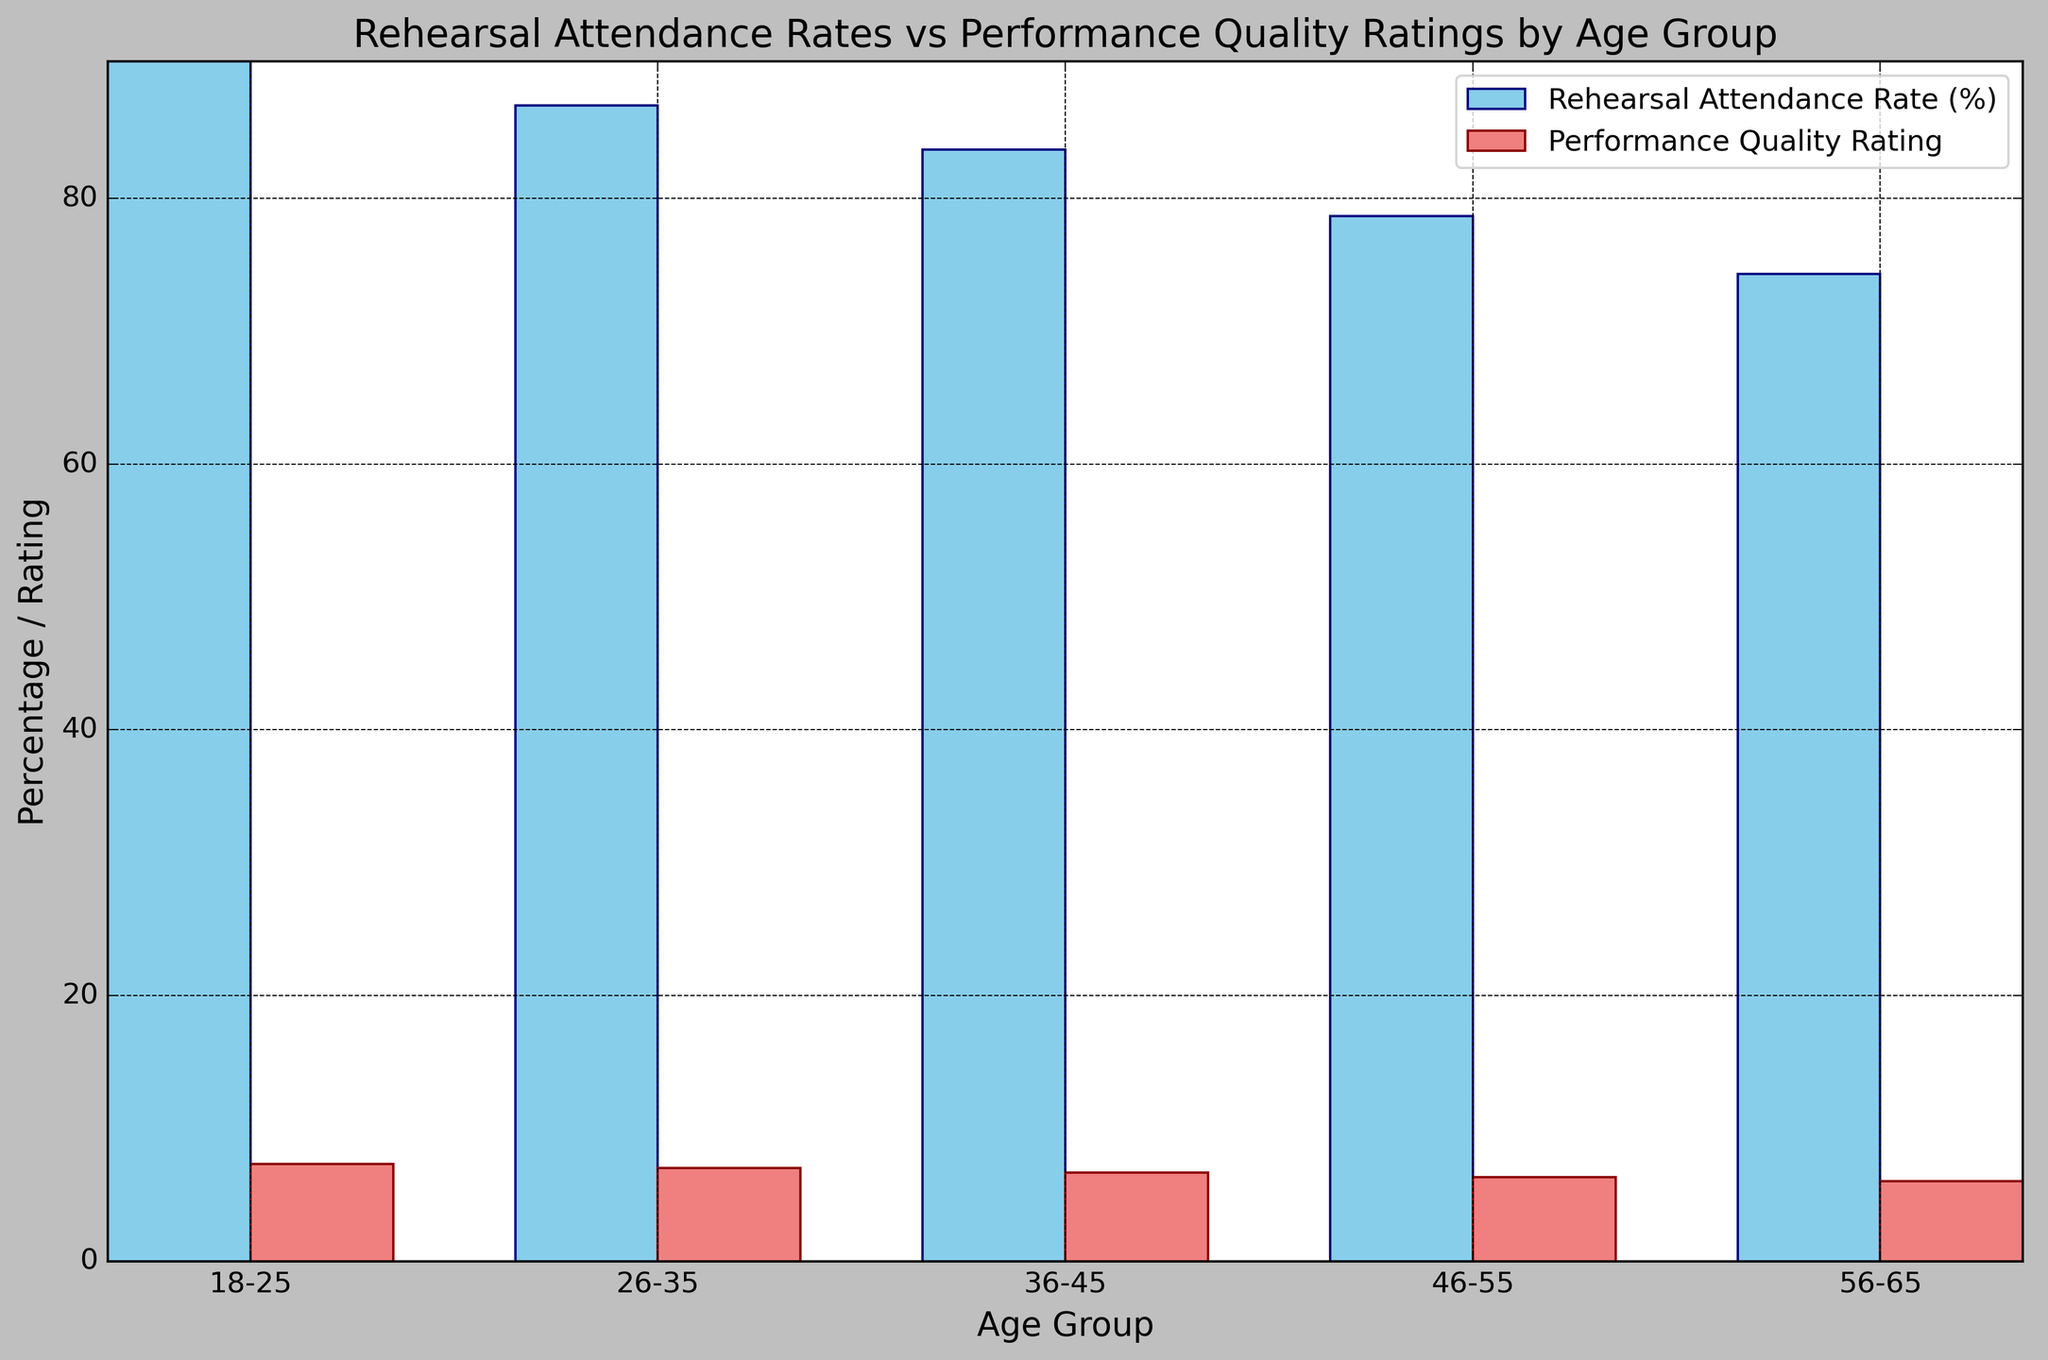What's the average rehearsal attendance rate for the 18-25 age group? To find the average, sum the attendance rates for the 18-25 age group and divide by the number of data points. (95 + 86 + 90) / 3 = 271 / 3, so the average is approximately 90.33%
Answer: 90.33% Which age group has the highest average performance quality rating? Compare the average performance quality rating among all age groups. 18-25: (8+6+8)/3 = 7.33, 26-35: (7+8+6)/3 = 7, 36-45: (7+6+7)/3 = 6.67, 46-55: (6+8+5)/3 = 6.33, 56-65: (6+7+5)/3 = 6. 18-25 has the highest average quality rating at 7.33.
Answer: 18-25 Which age group has the lowest rehearsal attendance rate? Compare the average rehearsal attendance rates among all age groups. 18-25: 90.33%, 26-35: 87%, 36-45: 83.67%, 46-55: 78.67%, 56-65: 74.33%. The 56-65 age group has the lowest rate.
Answer: 56-65 Is the average rehearsal attendance rate higher or lower in the 26-35 age group compared to the 36-45 age group? The average attendance rate for 26-35 is 87%, while for 36-45 it is 83.67%. Therefore, it is higher in the 26-35 age group.
Answer: Higher By how much does the average performance quality rating decrease from the 18-25 age group to the 36-45 age group? Calculate the difference between the average performance quality ratings of the 18-25 and 36-45 age groups. 18-25: 7.33, 36-45: 6.67. The difference is 7.33 - 6.67 = 0.66.
Answer: 0.66 Which two age groups have the closest average performance quality ratings? Compare the average performance quality ratings to find the two closest. 18-25: 7.33, 26-35: 7, 36-45: 6.67, 46-55: 6.33, 56-65: 6. The 26-35 and 36-45 age groups have the closest ratings with a difference of 0.33.
Answer: 26-35 and 36-45 What is the width of each bar representing the rehearsal attendance rate? Observe the bars related to the rehearsal attendance rate, which are the blue bars. According to the plot's code, the width of each bar is 0.35.
Answer: 0.35 How do the rehearsal attendance rates for the 18-25 age group compare to those of the 46-55 age group? Calculate and compare the average rehearsal attendance rates: 18-25: 90.33%, 46-55: 78.67%. The 18-25 age group has a higher attendance rate.
Answer: Higher What noticeable pattern can be observed between rehearsal attendance rates and performance quality ratings across age groups? As age increases, both rehearsal attendance rates and performance quality ratings generally decrease. This indicates a negative trend.
Answer: Decrease with age 